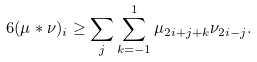<formula> <loc_0><loc_0><loc_500><loc_500>6 ( \mu \ast \nu ) _ { i } \geq \sum _ { j } \sum _ { k = - 1 } ^ { 1 } \mu _ { 2 i + j + k } \nu _ { 2 i - j } .</formula> 